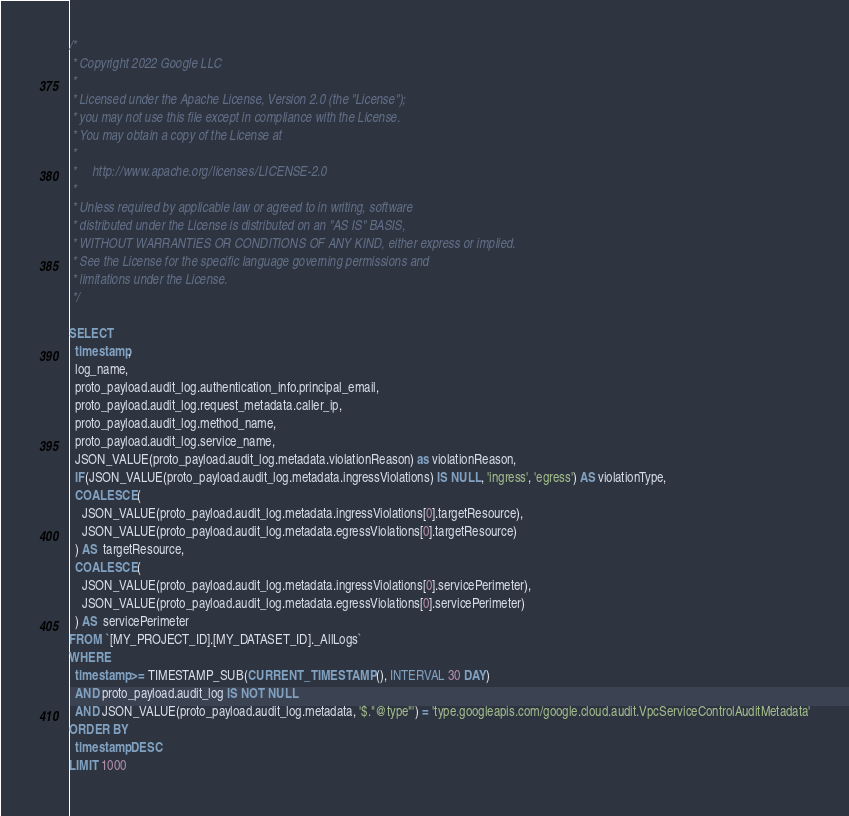<code> <loc_0><loc_0><loc_500><loc_500><_SQL_>/*
 * Copyright 2022 Google LLC
 *
 * Licensed under the Apache License, Version 2.0 (the "License");
 * you may not use this file except in compliance with the License.
 * You may obtain a copy of the License at
 *
 *     http://www.apache.org/licenses/LICENSE-2.0
 *
 * Unless required by applicable law or agreed to in writing, software
 * distributed under the License is distributed on an "AS IS" BASIS,
 * WITHOUT WARRANTIES OR CONDITIONS OF ANY KIND, either express or implied.
 * See the License for the specific language governing permissions and
 * limitations under the License.
 */

SELECT
  timestamp,
  log_name,
  proto_payload.audit_log.authentication_info.principal_email,
  proto_payload.audit_log.request_metadata.caller_ip,
  proto_payload.audit_log.method_name,
  proto_payload.audit_log.service_name,
  JSON_VALUE(proto_payload.audit_log.metadata.violationReason) as violationReason, 
  IF(JSON_VALUE(proto_payload.audit_log.metadata.ingressViolations) IS NULL, 'ingress', 'egress') AS violationType,
  COALESCE(
    JSON_VALUE(proto_payload.audit_log.metadata.ingressViolations[0].targetResource),
    JSON_VALUE(proto_payload.audit_log.metadata.egressViolations[0].targetResource)
  ) AS  targetResource,
  COALESCE(
    JSON_VALUE(proto_payload.audit_log.metadata.ingressViolations[0].servicePerimeter),
    JSON_VALUE(proto_payload.audit_log.metadata.egressViolations[0].servicePerimeter)
  ) AS  servicePerimeter
FROM `[MY_PROJECT_ID].[MY_DATASET_ID]._AllLogs`
WHERE
  timestamp >= TIMESTAMP_SUB(CURRENT_TIMESTAMP(), INTERVAL 30 DAY)
  AND proto_payload.audit_log IS NOT NULL
  AND JSON_VALUE(proto_payload.audit_log.metadata, '$."@type"') = 'type.googleapis.com/google.cloud.audit.VpcServiceControlAuditMetadata'
ORDER BY
  timestamp DESC
LIMIT 1000</code> 